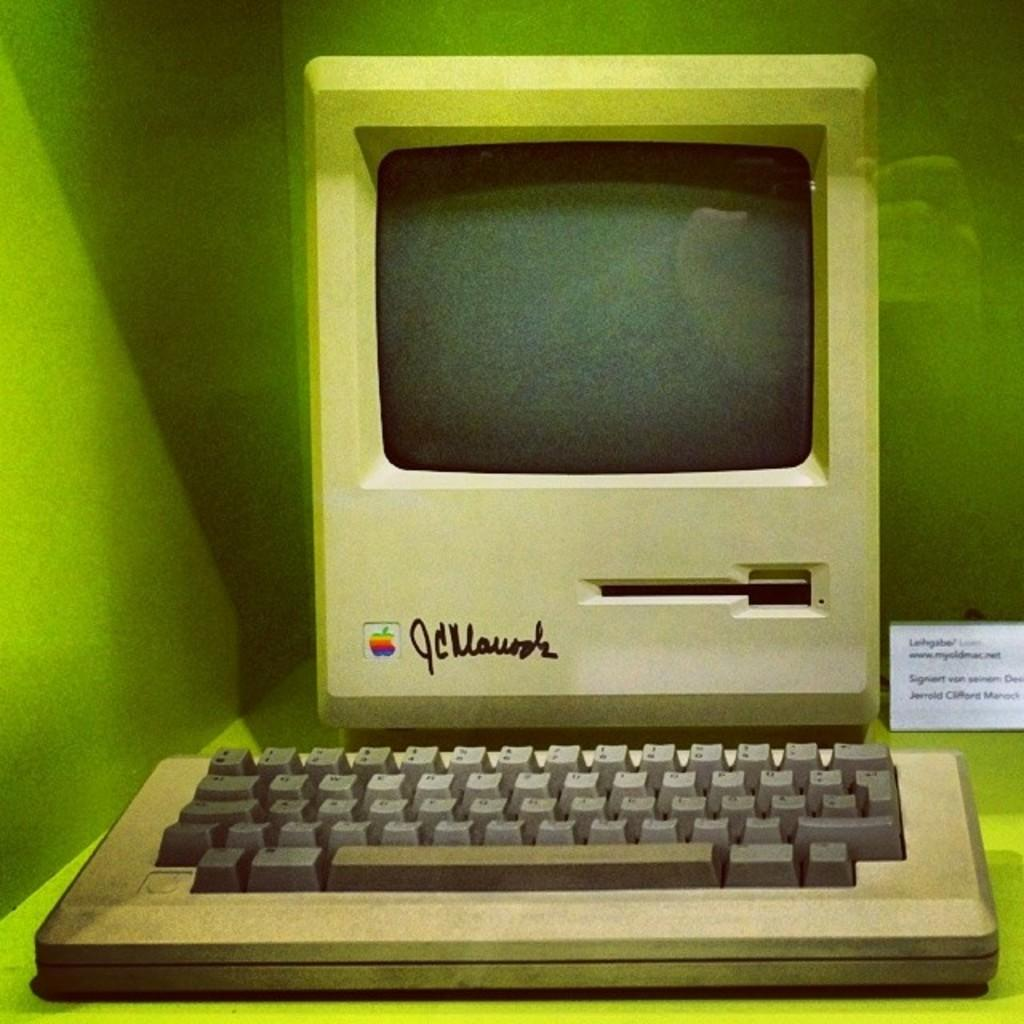Provide a one-sentence caption for the provided image. An old apple desktop computer on display with a signature to the right of the Apple logo. 